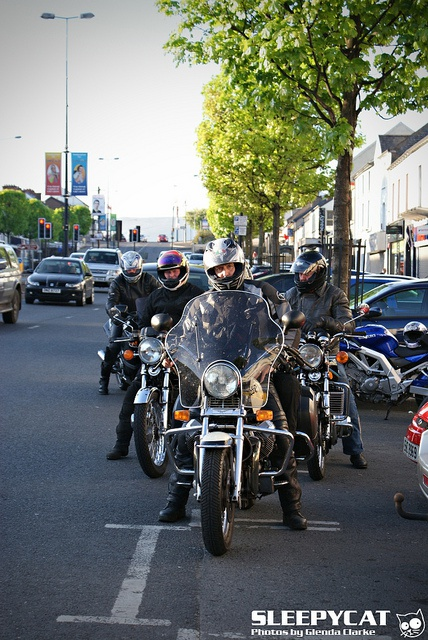Describe the objects in this image and their specific colors. I can see motorcycle in darkgray, black, and gray tones, people in darkgray, black, and gray tones, motorcycle in darkgray, black, gray, and navy tones, motorcycle in darkgray, black, gray, and white tones, and motorcycle in darkgray, black, gray, navy, and lightgray tones in this image. 